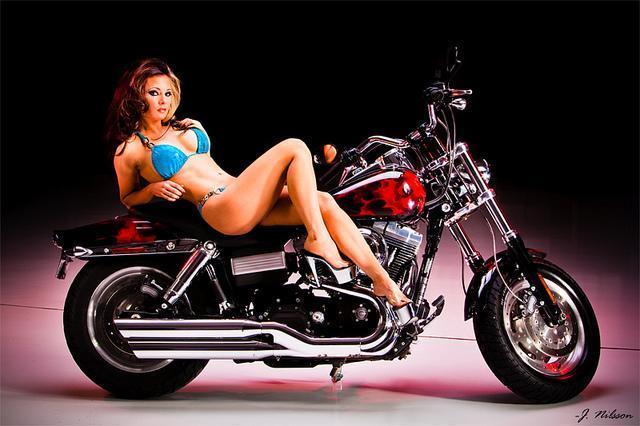How many orange cars are there in the picture?
Give a very brief answer. 0. 